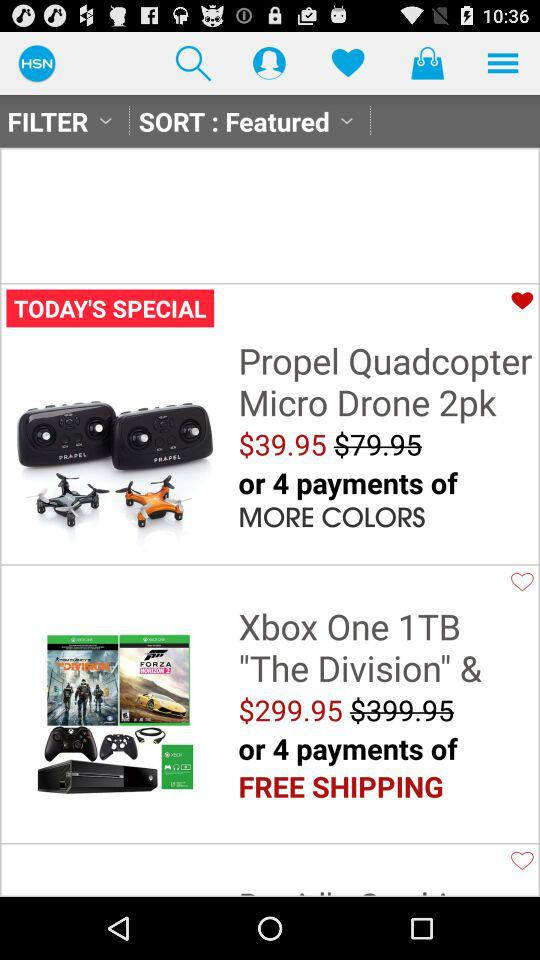After how many payments we will get free shipping?
When the provided information is insufficient, respond with <no answer>. <no answer> 